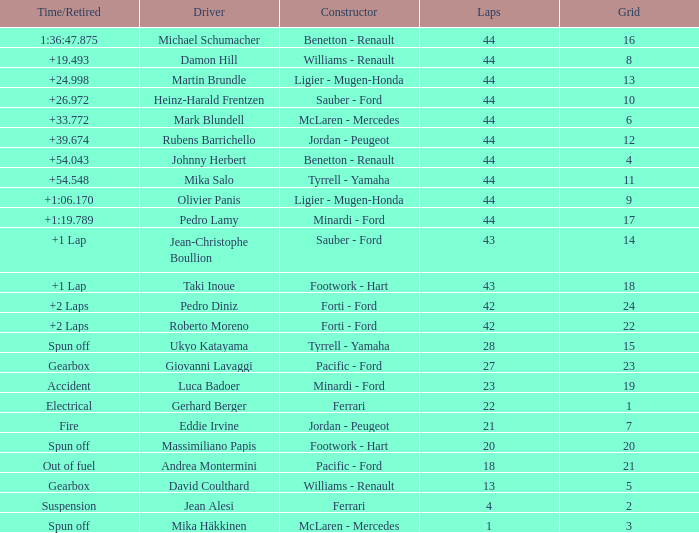What is the high lap total for cards with a grid larger than 21, and a Time/Retired of +2 laps? 42.0. 